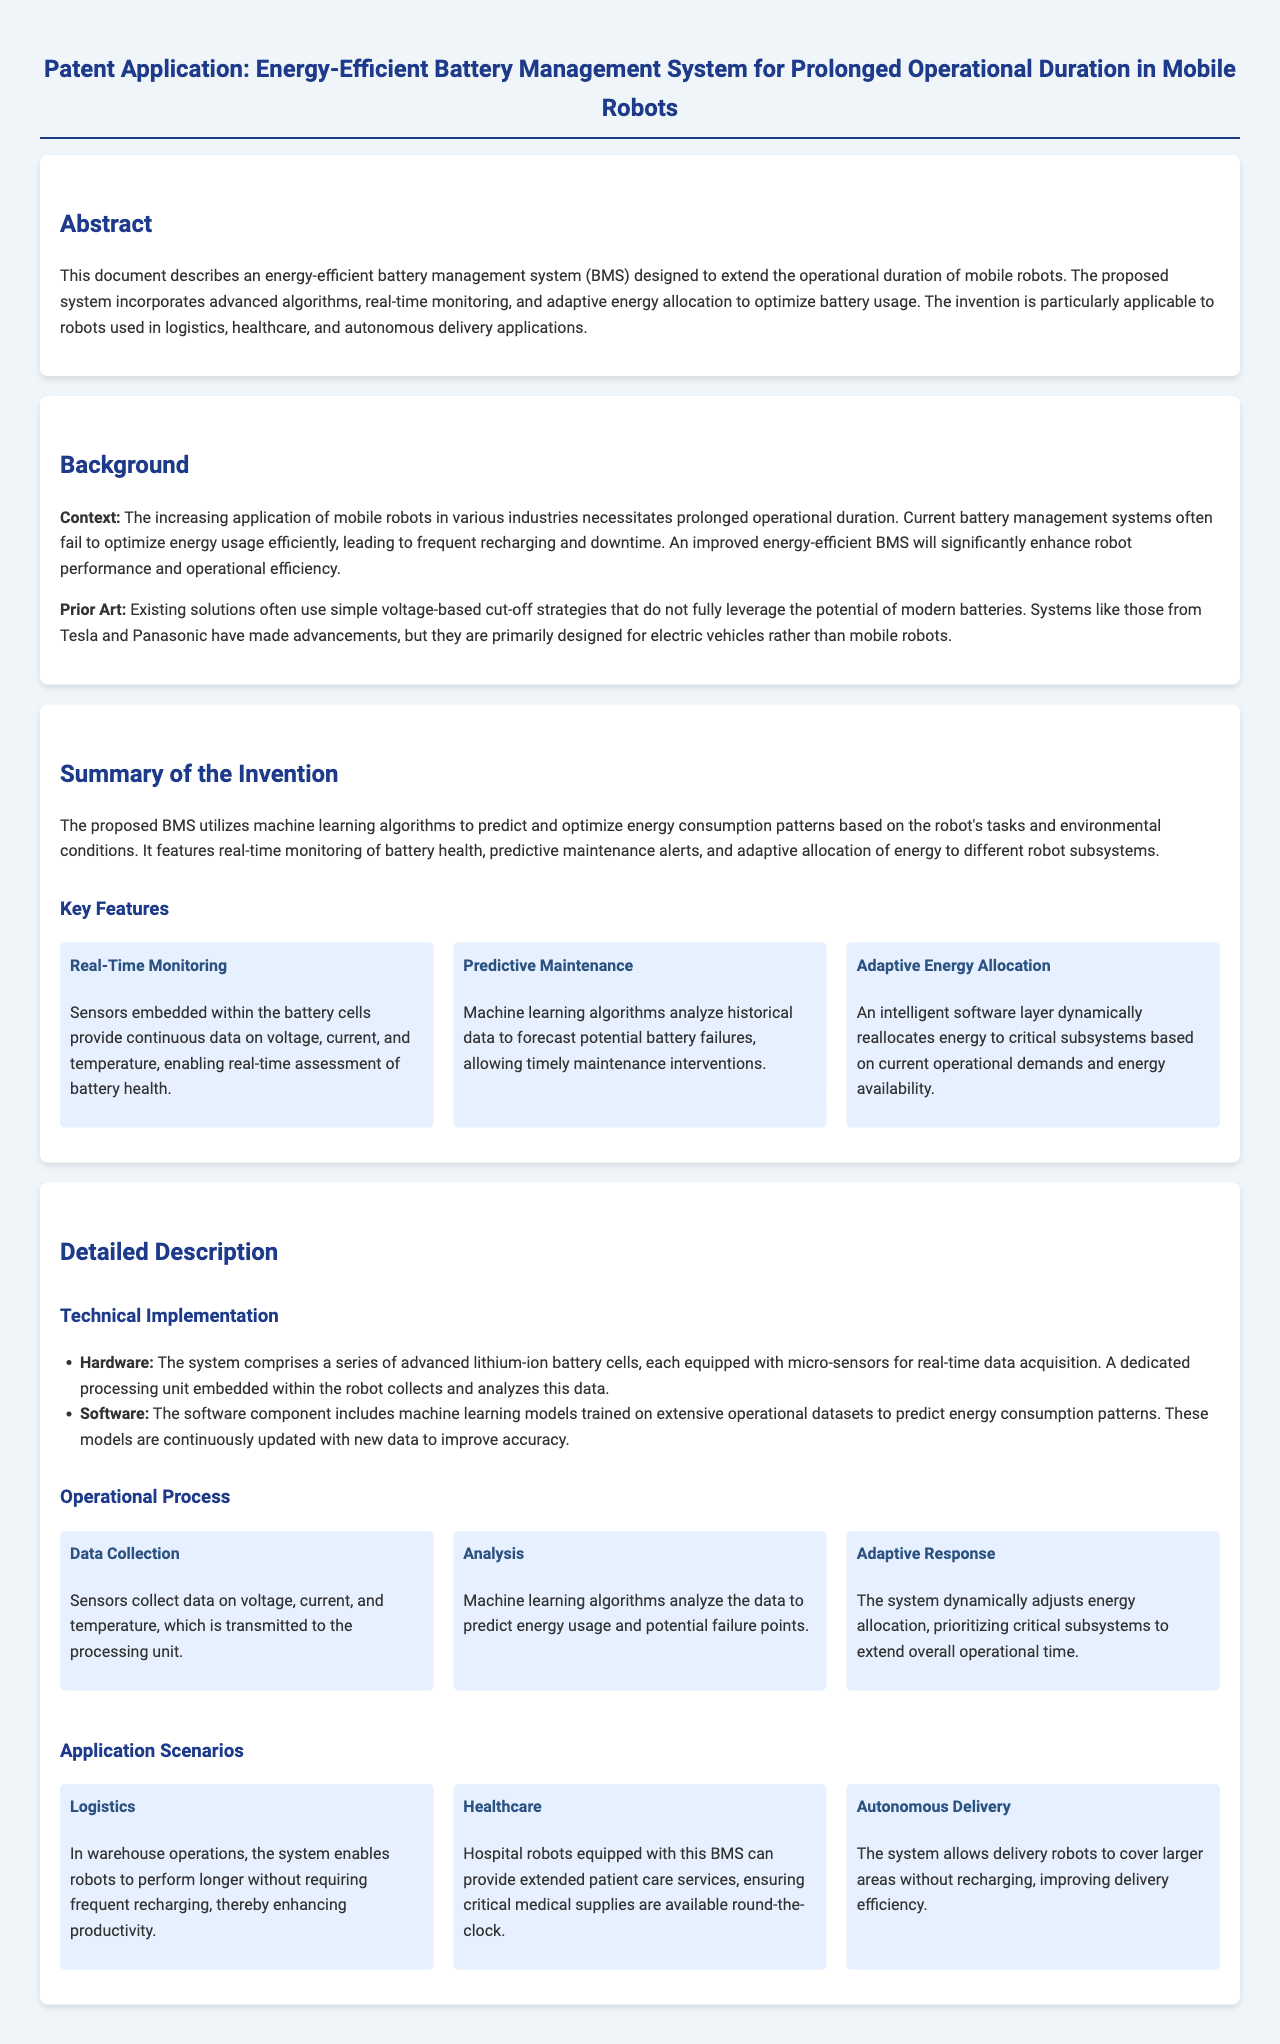What does the invention aim to improve? The invention aims to improve energy efficiency in battery management systems for mobile robots.
Answer: Energy efficiency What technology does the proposed BMS utilize? The proposed BMS utilizes machine learning algorithms.
Answer: Machine learning algorithms What key feature allows the BMS to monitor battery health? The key feature that allows monitoring is real-time monitoring with embedded sensors.
Answer: Real-time monitoring In which applications is the BMS primarily designed to be used? The BMS is primarily designed for logistics, healthcare, and autonomous delivery applications.
Answer: Logistics, healthcare, and autonomous delivery How does the system respond to critical subsystem demands? The system responds by dynamically reallocating energy to critical subsystems based on demands.
Answer: Dynamically reallocating energy How many steps are involved in the operational process described? The operational process involves three steps: Data Collection, Analysis, and Adaptive Response.
Answer: Three steps What type of battery cells does the system comprise? The system comprises advanced lithium-ion battery cells.
Answer: Lithium-ion battery cells What problem do existing battery management systems face? Existing systems often fail to optimize energy usage efficiently.
Answer: Optimize energy usage 